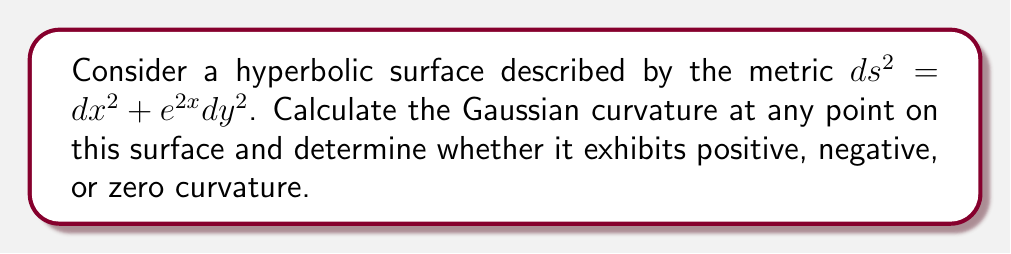Could you help me with this problem? To analyze the curvature of this non-Euclidean surface, we'll use the formula for Gaussian curvature in terms of the metric tensor.

Step 1: Identify the metric tensor components
From the given metric $ds^2 = dx^2 + e^{2x}dy^2$, we can identify:
$g_{11} = 1$, $g_{12} = g_{21} = 0$, $g_{22} = e^{2x}$

Step 2: Calculate the determinant of the metric tensor
$g = \det(g_{ij}) = g_{11}g_{22} - g_{12}g_{21} = 1 \cdot e^{2x} - 0 = e^{2x}$

Step 3: Calculate the Christoffel symbols
We need to calculate $\Gamma^k_{ij}$ using the formula:
$\Gamma^k_{ij} = \frac{1}{2}g^{kl}(\partial_i g_{jl} + \partial_j g_{il} - \partial_l g_{ij})$

The non-zero Christoffel symbols are:
$\Gamma^1_{22} = -e^{2x}$
$\Gamma^2_{12} = \Gamma^2_{21} = 1$

Step 4: Calculate the Riemann curvature tensor
The Riemann curvature tensor is given by:
$R^i_{jkl} = \partial_k \Gamma^i_{jl} - \partial_l \Gamma^i_{jk} + \Gamma^m_{jl}\Gamma^i_{mk} - \Gamma^m_{jk}\Gamma^i_{ml}$

The only non-zero component is:
$R^1_{212} = -1$

Step 5: Calculate the Gaussian curvature
The Gaussian curvature K is given by:
$K = \frac{R^1_{212}R^2_{121}}{g}$

$K = \frac{(-1)(-1)}{e^{2x}} = e^{-2x}$

Step 6: Analyze the curvature
Since $e^{-2x}$ is always positive for any real value of x, the Gaussian curvature is always negative.
Answer: $K = e^{-2x}$; negative curvature 